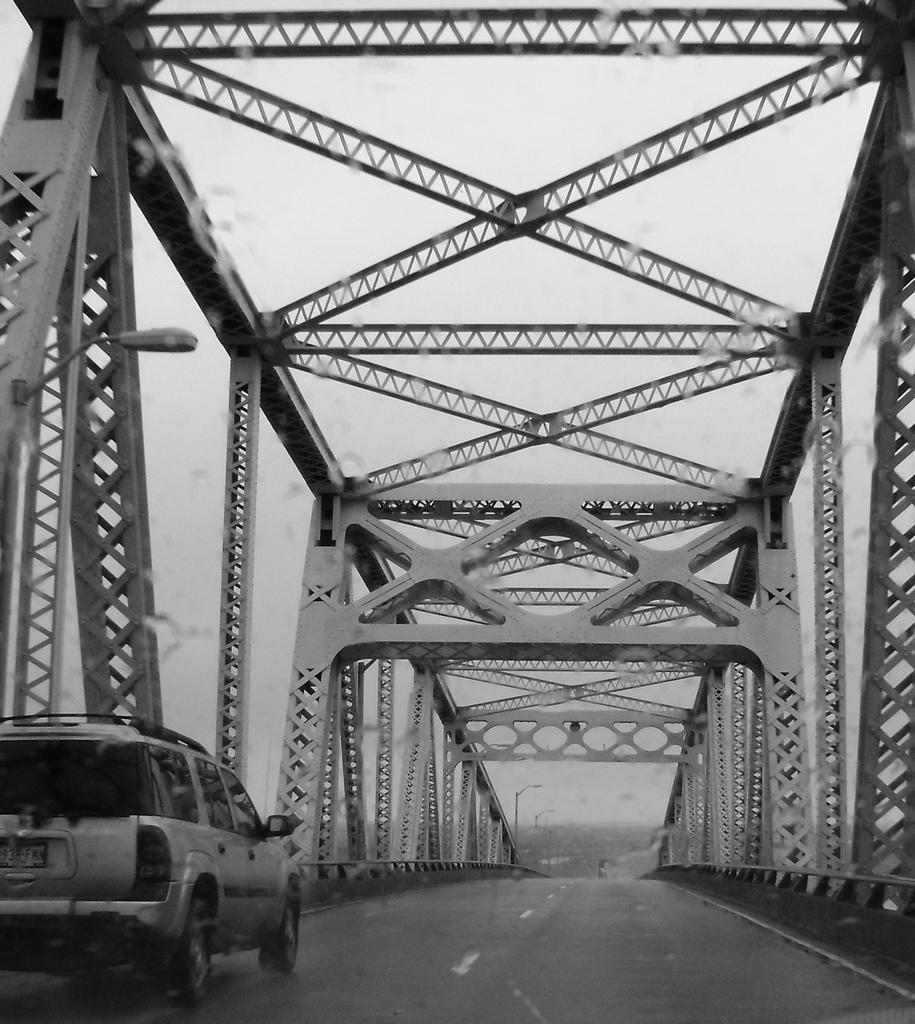What is happening in the foreground of the image? There is a vehicle moving on a bridge in the foreground of the image. What is the color scheme of the image? The image is in black and white. What can be seen in the background of the image? There are poles in the background of the image. What is visible at the top of the image? The sky is visible at the top of the image. What type of teaching method is being used by the hot air balloon in the image? There is no hot air balloon present in the image, and therefore no teaching method can be observed. What songs are being sung by the birds in the image? There are no birds or songs present in the image. 